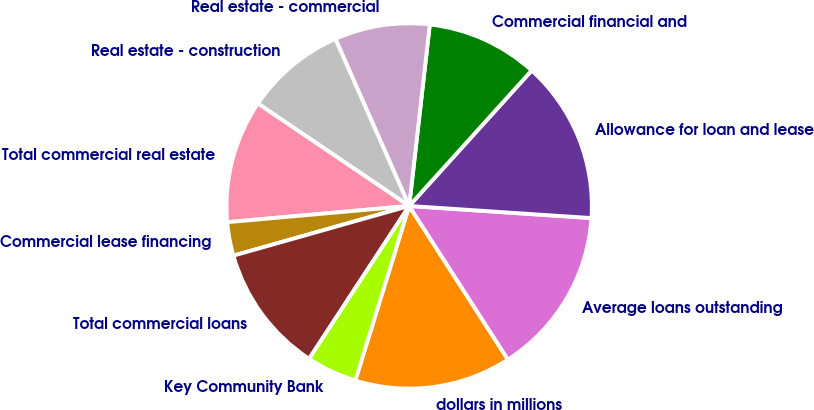<chart> <loc_0><loc_0><loc_500><loc_500><pie_chart><fcel>dollars in millions<fcel>Average loans outstanding<fcel>Allowance for loan and lease<fcel>Commercial financial and<fcel>Real estate - commercial<fcel>Real estate - construction<fcel>Total commercial real estate<fcel>Commercial lease financing<fcel>Total commercial loans<fcel>Key Community Bank<nl><fcel>13.86%<fcel>14.85%<fcel>14.36%<fcel>9.9%<fcel>8.42%<fcel>8.91%<fcel>10.89%<fcel>2.97%<fcel>11.39%<fcel>4.46%<nl></chart> 